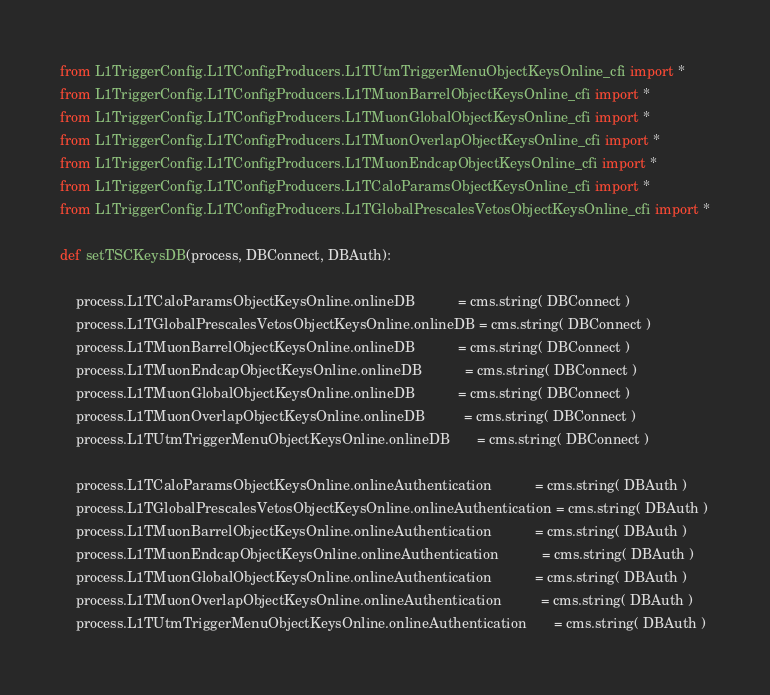<code> <loc_0><loc_0><loc_500><loc_500><_Python_>from L1TriggerConfig.L1TConfigProducers.L1TUtmTriggerMenuObjectKeysOnline_cfi import *
from L1TriggerConfig.L1TConfigProducers.L1TMuonBarrelObjectKeysOnline_cfi import *
from L1TriggerConfig.L1TConfigProducers.L1TMuonGlobalObjectKeysOnline_cfi import *
from L1TriggerConfig.L1TConfigProducers.L1TMuonOverlapObjectKeysOnline_cfi import *
from L1TriggerConfig.L1TConfigProducers.L1TMuonEndcapObjectKeysOnline_cfi import *
from L1TriggerConfig.L1TConfigProducers.L1TCaloParamsObjectKeysOnline_cfi import *
from L1TriggerConfig.L1TConfigProducers.L1TGlobalPrescalesVetosObjectKeysOnline_cfi import *

def setTSCKeysDB(process, DBConnect, DBAuth):

    process.L1TCaloParamsObjectKeysOnline.onlineDB           = cms.string( DBConnect )
    process.L1TGlobalPrescalesVetosObjectKeysOnline.onlineDB = cms.string( DBConnect )
    process.L1TMuonBarrelObjectKeysOnline.onlineDB           = cms.string( DBConnect )
    process.L1TMuonEndcapObjectKeysOnline.onlineDB           = cms.string( DBConnect )
    process.L1TMuonGlobalObjectKeysOnline.onlineDB           = cms.string( DBConnect )
    process.L1TMuonOverlapObjectKeysOnline.onlineDB          = cms.string( DBConnect )
    process.L1TUtmTriggerMenuObjectKeysOnline.onlineDB       = cms.string( DBConnect )

    process.L1TCaloParamsObjectKeysOnline.onlineAuthentication           = cms.string( DBAuth )
    process.L1TGlobalPrescalesVetosObjectKeysOnline.onlineAuthentication = cms.string( DBAuth )
    process.L1TMuonBarrelObjectKeysOnline.onlineAuthentication           = cms.string( DBAuth )
    process.L1TMuonEndcapObjectKeysOnline.onlineAuthentication           = cms.string( DBAuth )
    process.L1TMuonGlobalObjectKeysOnline.onlineAuthentication           = cms.string( DBAuth )
    process.L1TMuonOverlapObjectKeysOnline.onlineAuthentication          = cms.string( DBAuth )
    process.L1TUtmTriggerMenuObjectKeysOnline.onlineAuthentication       = cms.string( DBAuth )


</code> 